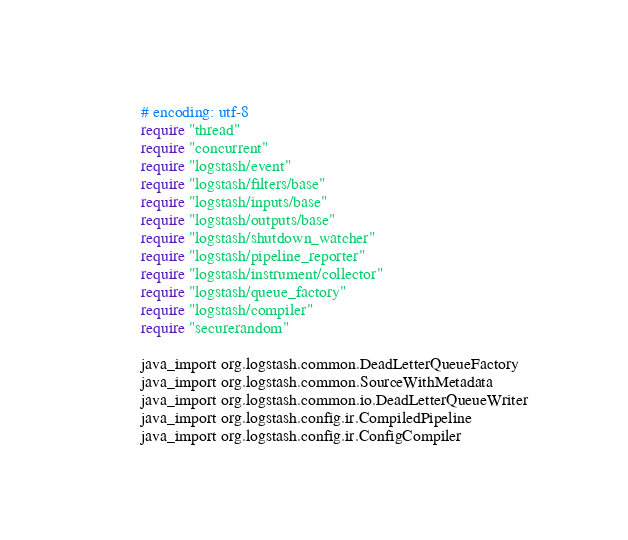<code> <loc_0><loc_0><loc_500><loc_500><_Ruby_># encoding: utf-8
require "thread"
require "concurrent"
require "logstash/event"
require "logstash/filters/base"
require "logstash/inputs/base"
require "logstash/outputs/base"
require "logstash/shutdown_watcher"
require "logstash/pipeline_reporter"
require "logstash/instrument/collector"
require "logstash/queue_factory"
require "logstash/compiler"
require "securerandom"

java_import org.logstash.common.DeadLetterQueueFactory
java_import org.logstash.common.SourceWithMetadata
java_import org.logstash.common.io.DeadLetterQueueWriter
java_import org.logstash.config.ir.CompiledPipeline
java_import org.logstash.config.ir.ConfigCompiler
</code> 